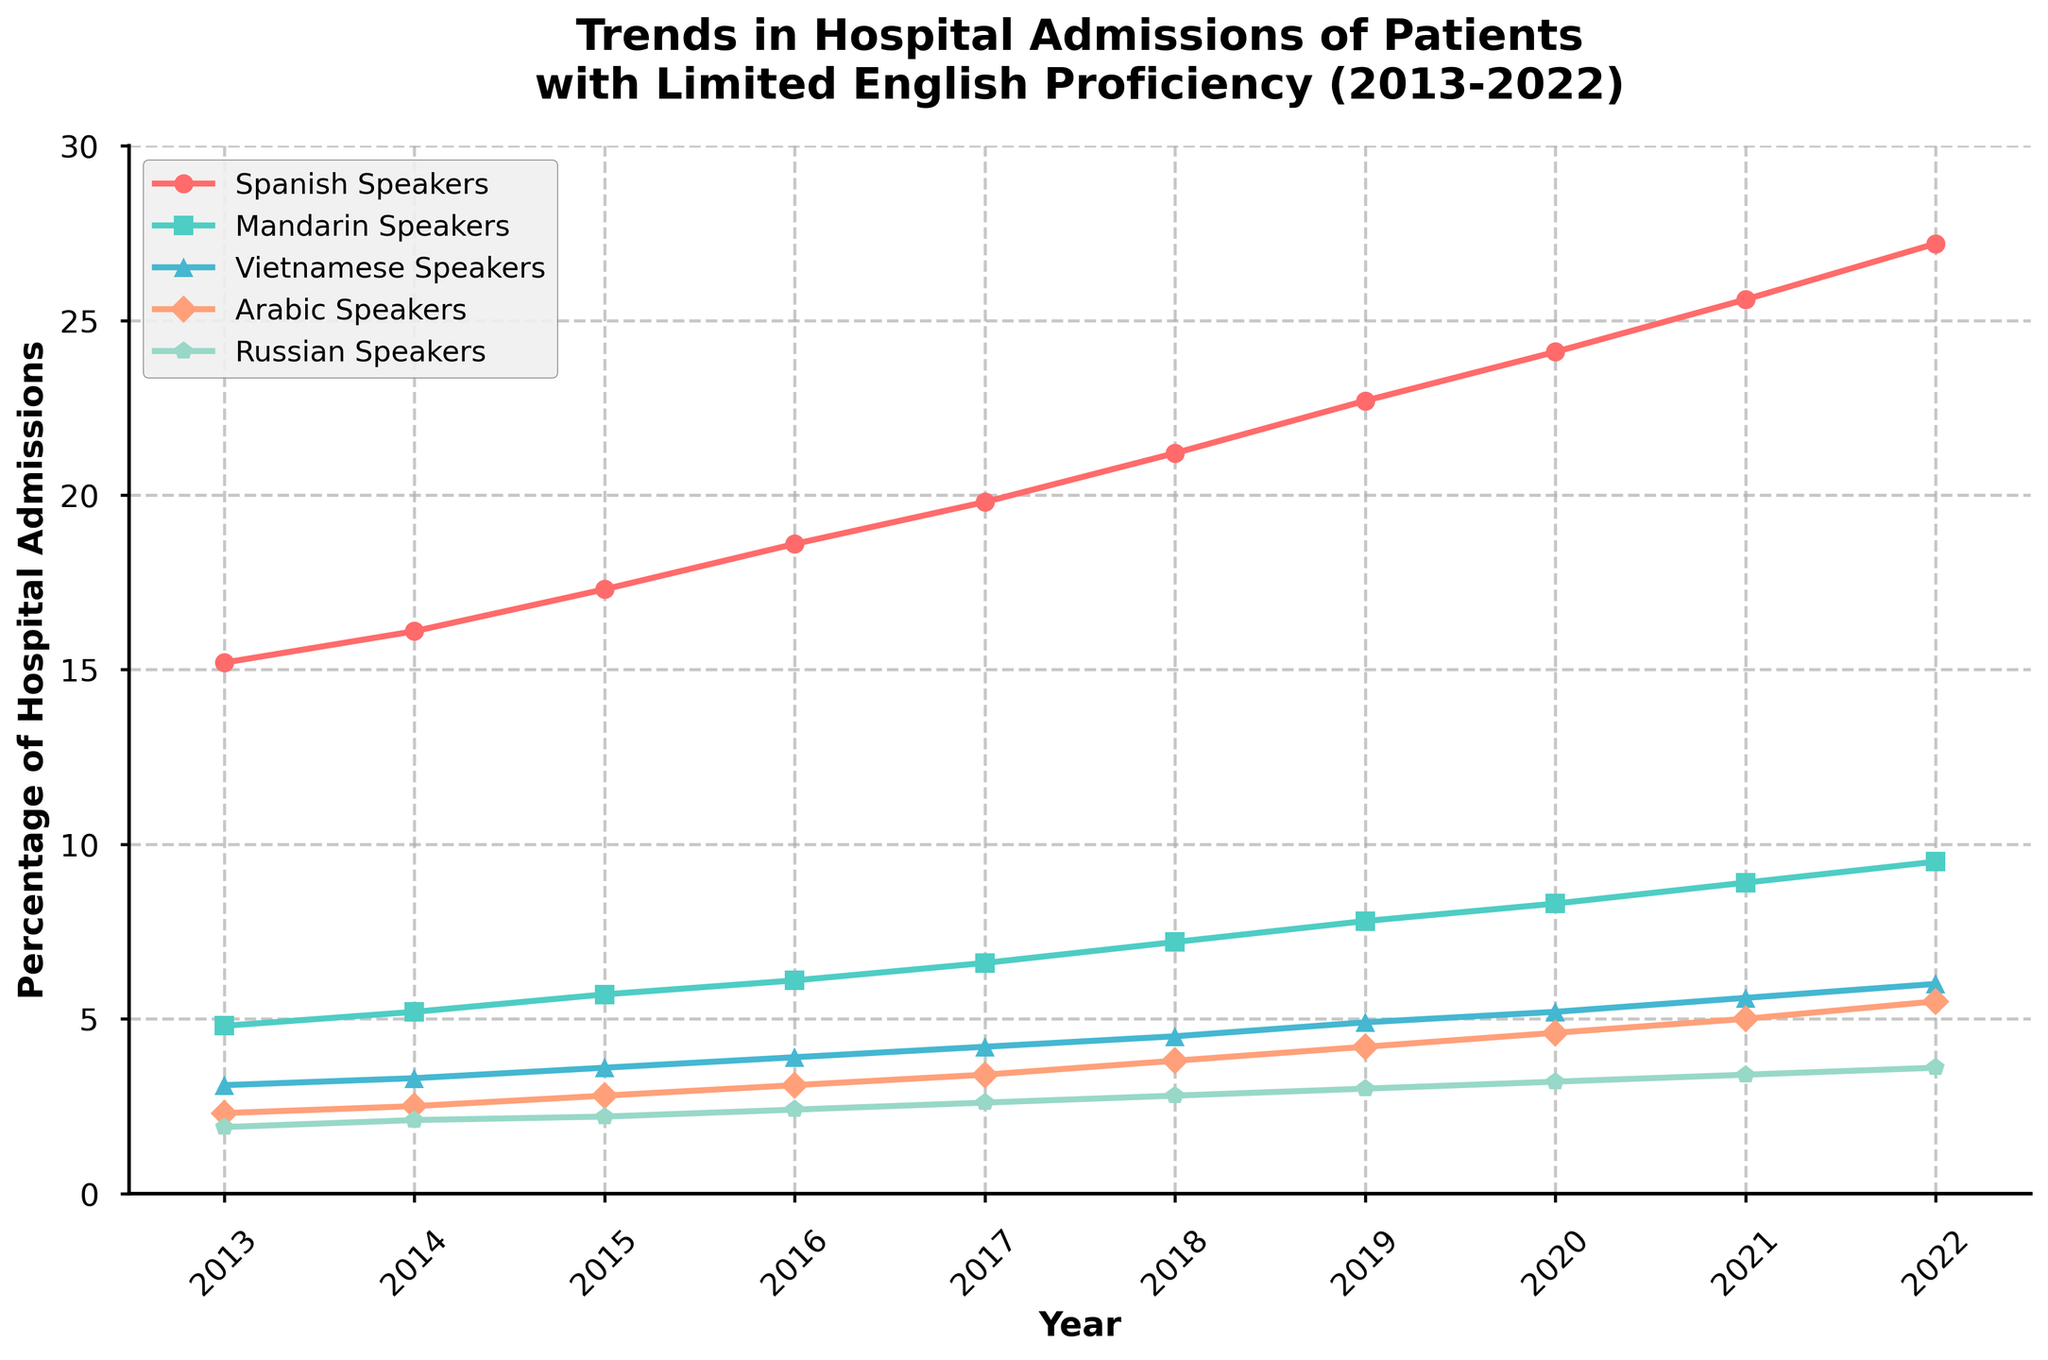Which language group had the highest percentage of hospital admissions in 2013? To find the highest percentage in 2013, compare the values of all language groups for that year. Spanish Speakers have the highest value at 15.2%.
Answer: Spanish Speakers What is the total increase in hospital admissions percentage for Russian Speakers from 2013 to 2022? Subtract the 2013 percentage of Russian Speakers (1.9) from the 2022 percentage (3.6). 3.6 - 1.9 equals 1.7.
Answer: 1.7 How did the hospital admissions percentage of Mandarin Speakers change from 2017 to 2018? Subtract the 2017 value for Mandarin Speakers (6.6) from the 2018 value (7.2). 7.2 - 6.6 equals 0.6.
Answer: 0.6 Between which two consecutive years did Vietnamese Speakers experience the highest increase in hospital admissions percentage? Calculate the difference in percentages for each consecutive year, then find the maximum difference. The largest increase for Vietnamese Speakers occurred between 2021 (5.6) and 2022 (6.0), which is 0.4.
Answer: 2021 and 2022 Which language had the smallest increase in hospital admissions percentage over the span of 2013 to 2022? Calculate the difference in percentages from 2013 to 2022 for each language. Russian Speakers had the smallest increase (3.6 - 1.9 = 1.7).
Answer: Russian Speakers In which year did Arabic Speakers reach a hospital admissions percentage of 5.0? Look for the year where Arabic Speakers' percentage value is 5.0. This occurred in 2021.
Answer: 2021 Which two language groups had the closest hospital admissions percentages in 2020? Compare the values for all language groups in 2020. Vietnamese Speakers (5.2) and Arabic Speakers (4.6) were the closest, with a difference of 0.6.
Answer: Vietnamese and Arabic Speakers How much higher was the hospital admissions percentage for Spanish Speakers compared to Mandarin Speakers in 2022? Subtract the 2022 percentage for Mandarin Speakers (9.5) from the 2022 percentage for Spanish Speakers (27.2). 27.2 - 9.5 equals 17.7.
Answer: 17.7 What was the average hospital admissions percentage for Arabic Speakers between 2018 and 2022? Add the percentages for Arabic Speakers from 2018 to 2022 (3.8 + 4.2 + 4.6 + 5.0 + 5.5 = 23.1) and divide by 5. The result is 4.62.
Answer: 4.62 